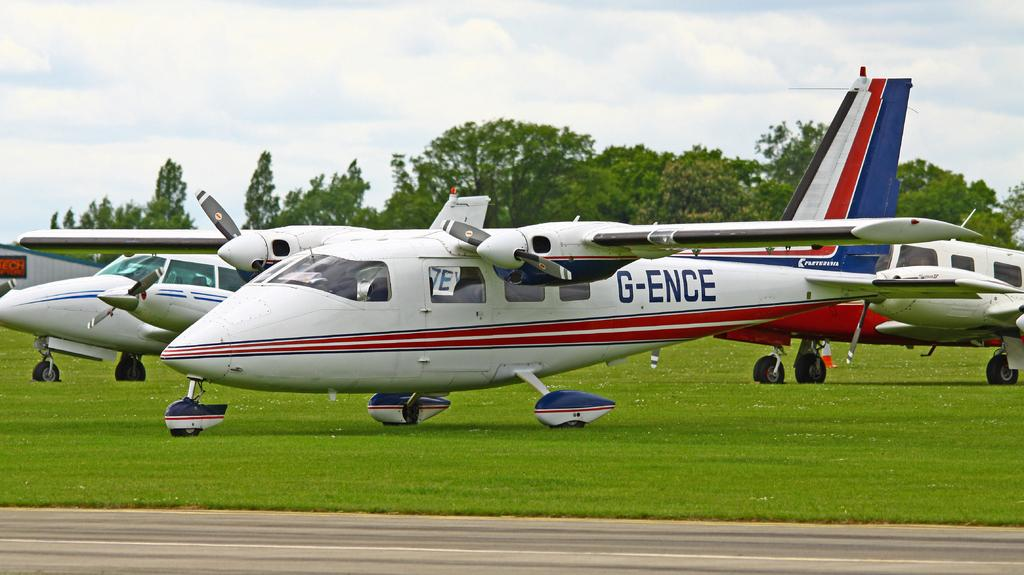What is the main subject in the center of the image? There are aeroplanes in the center of the image. What type of terrain is visible at the bottom of the image? There is grass at the bottom of the image. What type of transportation infrastructure can be seen in the image? There is a road in the image. What type of natural environment is visible in the background of the image? There are trees in the background of the image. What type of toy can be seen in the frame of the image? There is no toy present in the image, and the term "frame" is not applicable to the image itself. 